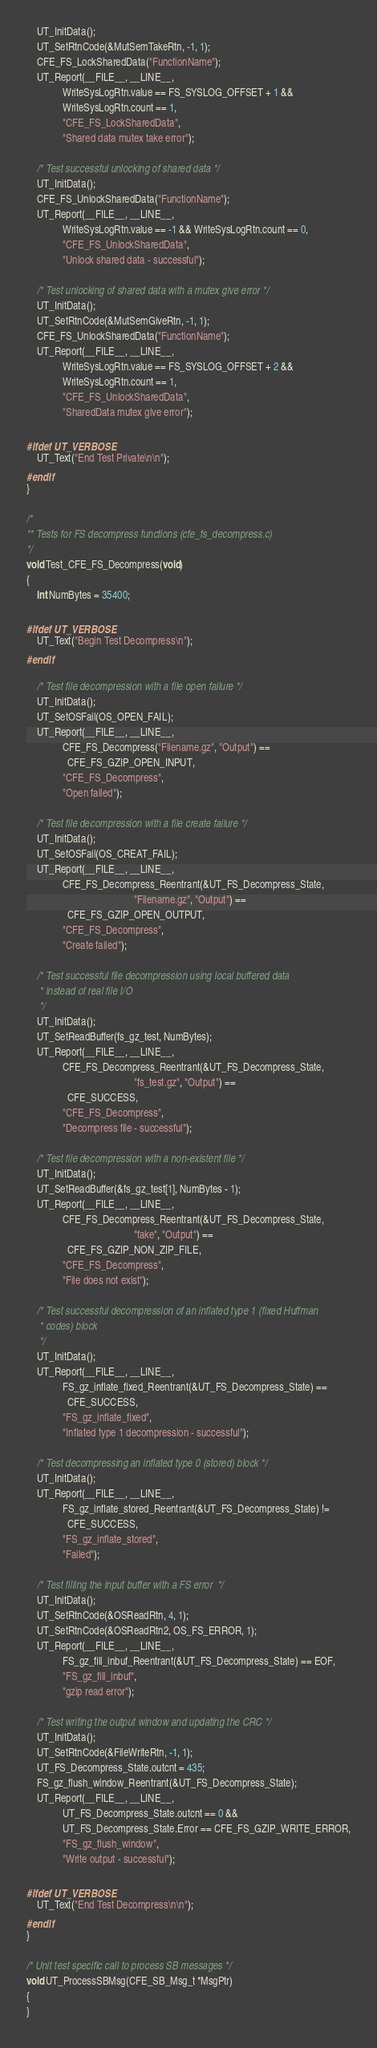Convert code to text. <code><loc_0><loc_0><loc_500><loc_500><_C_>    UT_InitData();
    UT_SetRtnCode(&MutSemTakeRtn, -1, 1);
    CFE_FS_LockSharedData("FunctionName");
    UT_Report(__FILE__, __LINE__,
              WriteSysLogRtn.value == FS_SYSLOG_OFFSET + 1 &&
              WriteSysLogRtn.count == 1,
              "CFE_FS_LockSharedData",
              "Shared data mutex take error");

    /* Test successful unlocking of shared data */
    UT_InitData();
    CFE_FS_UnlockSharedData("FunctionName");
    UT_Report(__FILE__, __LINE__,
              WriteSysLogRtn.value == -1 && WriteSysLogRtn.count == 0,
              "CFE_FS_UnlockSharedData",
              "Unlock shared data - successful");

    /* Test unlocking of shared data with a mutex give error */
    UT_InitData();
    UT_SetRtnCode(&MutSemGiveRtn, -1, 1);
    CFE_FS_UnlockSharedData("FunctionName");
    UT_Report(__FILE__, __LINE__,
              WriteSysLogRtn.value == FS_SYSLOG_OFFSET + 2 &&
              WriteSysLogRtn.count == 1,
              "CFE_FS_UnlockSharedData",
              "SharedData mutex give error");

#ifdef UT_VERBOSE
    UT_Text("End Test Private\n\n");
#endif
}

/*
** Tests for FS decompress functions (cfe_fs_decompress.c)
*/
void Test_CFE_FS_Decompress(void)
{
    int NumBytes = 35400;

#ifdef UT_VERBOSE
    UT_Text("Begin Test Decompress\n");
#endif

    /* Test file decompression with a file open failure */
    UT_InitData();
    UT_SetOSFail(OS_OPEN_FAIL);
    UT_Report(__FILE__, __LINE__,
              CFE_FS_Decompress("Filename.gz", "Output") ==
                CFE_FS_GZIP_OPEN_INPUT,
              "CFE_FS_Decompress",
              "Open failed");

    /* Test file decompression with a file create failure */
    UT_InitData();
    UT_SetOSFail(OS_CREAT_FAIL);
    UT_Report(__FILE__, __LINE__,
              CFE_FS_Decompress_Reentrant(&UT_FS_Decompress_State,
                                          "Filename.gz", "Output") ==
                CFE_FS_GZIP_OPEN_OUTPUT,
              "CFE_FS_Decompress",
              "Create failed");

    /* Test successful file decompression using local buffered data
     * instead of real file I/O
     */
    UT_InitData();
    UT_SetReadBuffer(fs_gz_test, NumBytes);
    UT_Report(__FILE__, __LINE__,
              CFE_FS_Decompress_Reentrant(&UT_FS_Decompress_State,
                                          "fs_test.gz", "Output") ==
                CFE_SUCCESS,
              "CFE_FS_Decompress",
              "Decompress file - successful");

    /* Test file decompression with a non-existent file */
    UT_InitData();
    UT_SetReadBuffer(&fs_gz_test[1], NumBytes - 1);
    UT_Report(__FILE__, __LINE__,
              CFE_FS_Decompress_Reentrant(&UT_FS_Decompress_State,
                                          "fake", "Output") ==
                CFE_FS_GZIP_NON_ZIP_FILE,
              "CFE_FS_Decompress",
              "File does not exist");

    /* Test successful decompression of an inflated type 1 (fixed Huffman
     * codes) block
     */
    UT_InitData();
    UT_Report(__FILE__, __LINE__,
              FS_gz_inflate_fixed_Reentrant(&UT_FS_Decompress_State) ==
                CFE_SUCCESS,
              "FS_gz_inflate_fixed",
              "Inflated type 1 decompression - successful");

    /* Test decompressing an inflated type 0 (stored) block */
    UT_InitData();
    UT_Report(__FILE__, __LINE__,
              FS_gz_inflate_stored_Reentrant(&UT_FS_Decompress_State) !=
                CFE_SUCCESS,
              "FS_gz_inflate_stored",
              "Failed");

    /* Test filling the input buffer with a FS error  */
    UT_InitData();
    UT_SetRtnCode(&OSReadRtn, 4, 1);
    UT_SetRtnCode(&OSReadRtn2, OS_FS_ERROR, 1);
    UT_Report(__FILE__, __LINE__,
              FS_gz_fill_inbuf_Reentrant(&UT_FS_Decompress_State) == EOF,
              "FS_gz_fill_inbuf",
              "gzip read error");

    /* Test writing the output window and updating the CRC */
    UT_InitData();
    UT_SetRtnCode(&FileWriteRtn, -1, 1);
    UT_FS_Decompress_State.outcnt = 435;
    FS_gz_flush_window_Reentrant(&UT_FS_Decompress_State);
    UT_Report(__FILE__, __LINE__,
              UT_FS_Decompress_State.outcnt == 0 &&
              UT_FS_Decompress_State.Error == CFE_FS_GZIP_WRITE_ERROR,
              "FS_gz_flush_window",
              "Write output - successful");

#ifdef UT_VERBOSE
    UT_Text("End Test Decompress\n\n");
#endif
}

/* Unit test specific call to process SB messages */
void UT_ProcessSBMsg(CFE_SB_Msg_t *MsgPtr)
{
}
</code> 